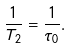Convert formula to latex. <formula><loc_0><loc_0><loc_500><loc_500>\frac { 1 } { T _ { 2 } } = \frac { 1 } { \tau _ { 0 } } .</formula> 